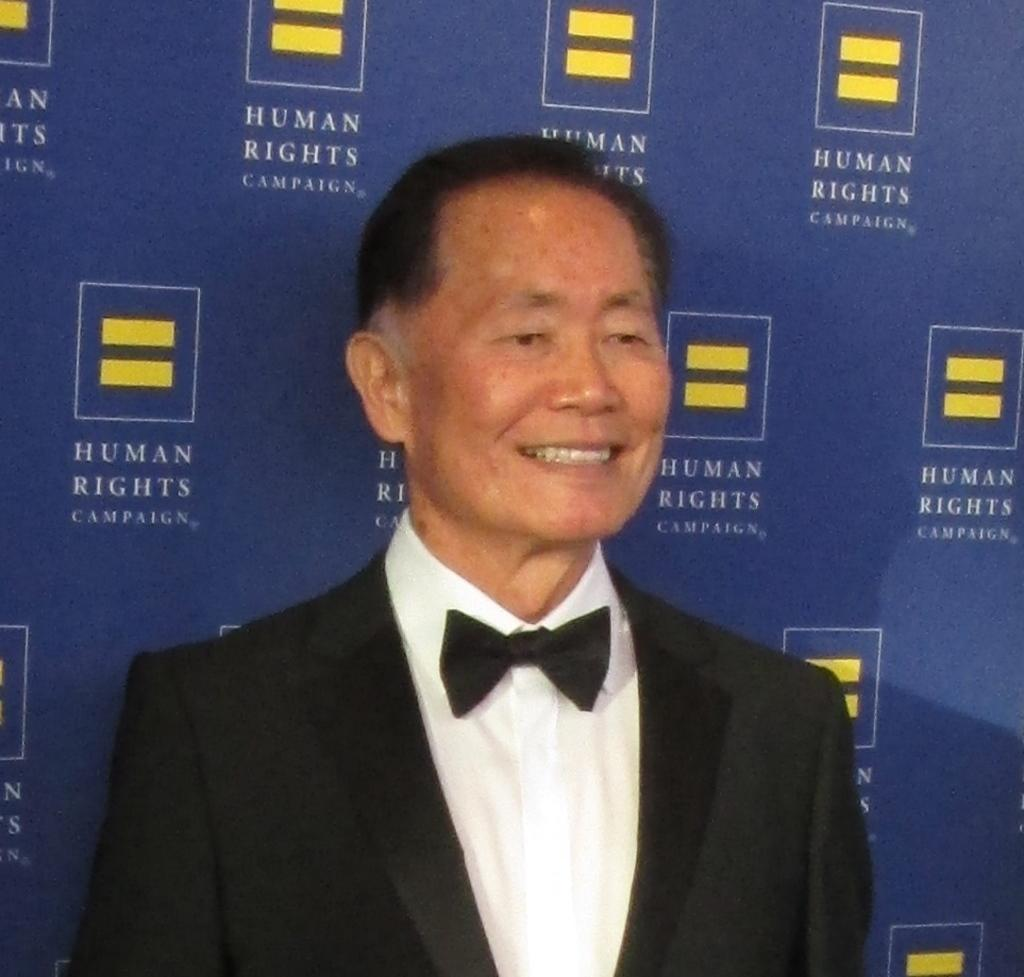Who is present in the image? There is a man in the image. What is the man doing in the image? The man is standing in the image. What is the man's facial expression in the image? The man is smiling in the image. What is the man wearing in the image? The man is wearing a black suit and a white shirt in the image. What can be seen in the background of the image? There is a blue color banner in the background of the image. Is there a woman in the image? No, there is no woman present in the image; it features a man. What type of business is being conducted in the image? There is no indication of any business being conducted in the image; it simply shows a man standing and smiling. 